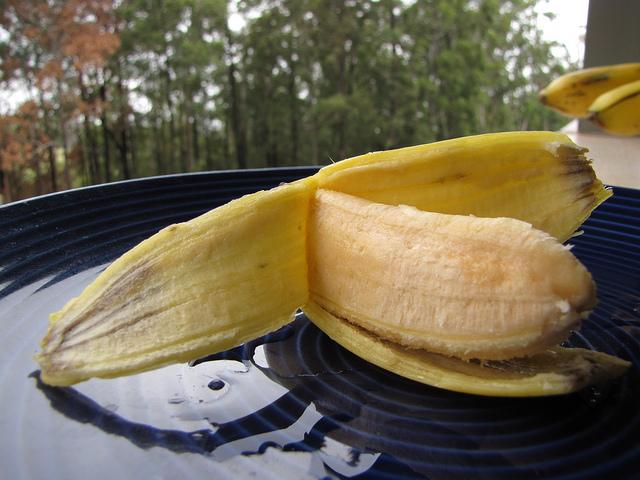Is the banana going to be eaten?
Concise answer only. Yes. Is the whole banana done?
Short answer required. No. What fruit is this?
Quick response, please. Banana. 